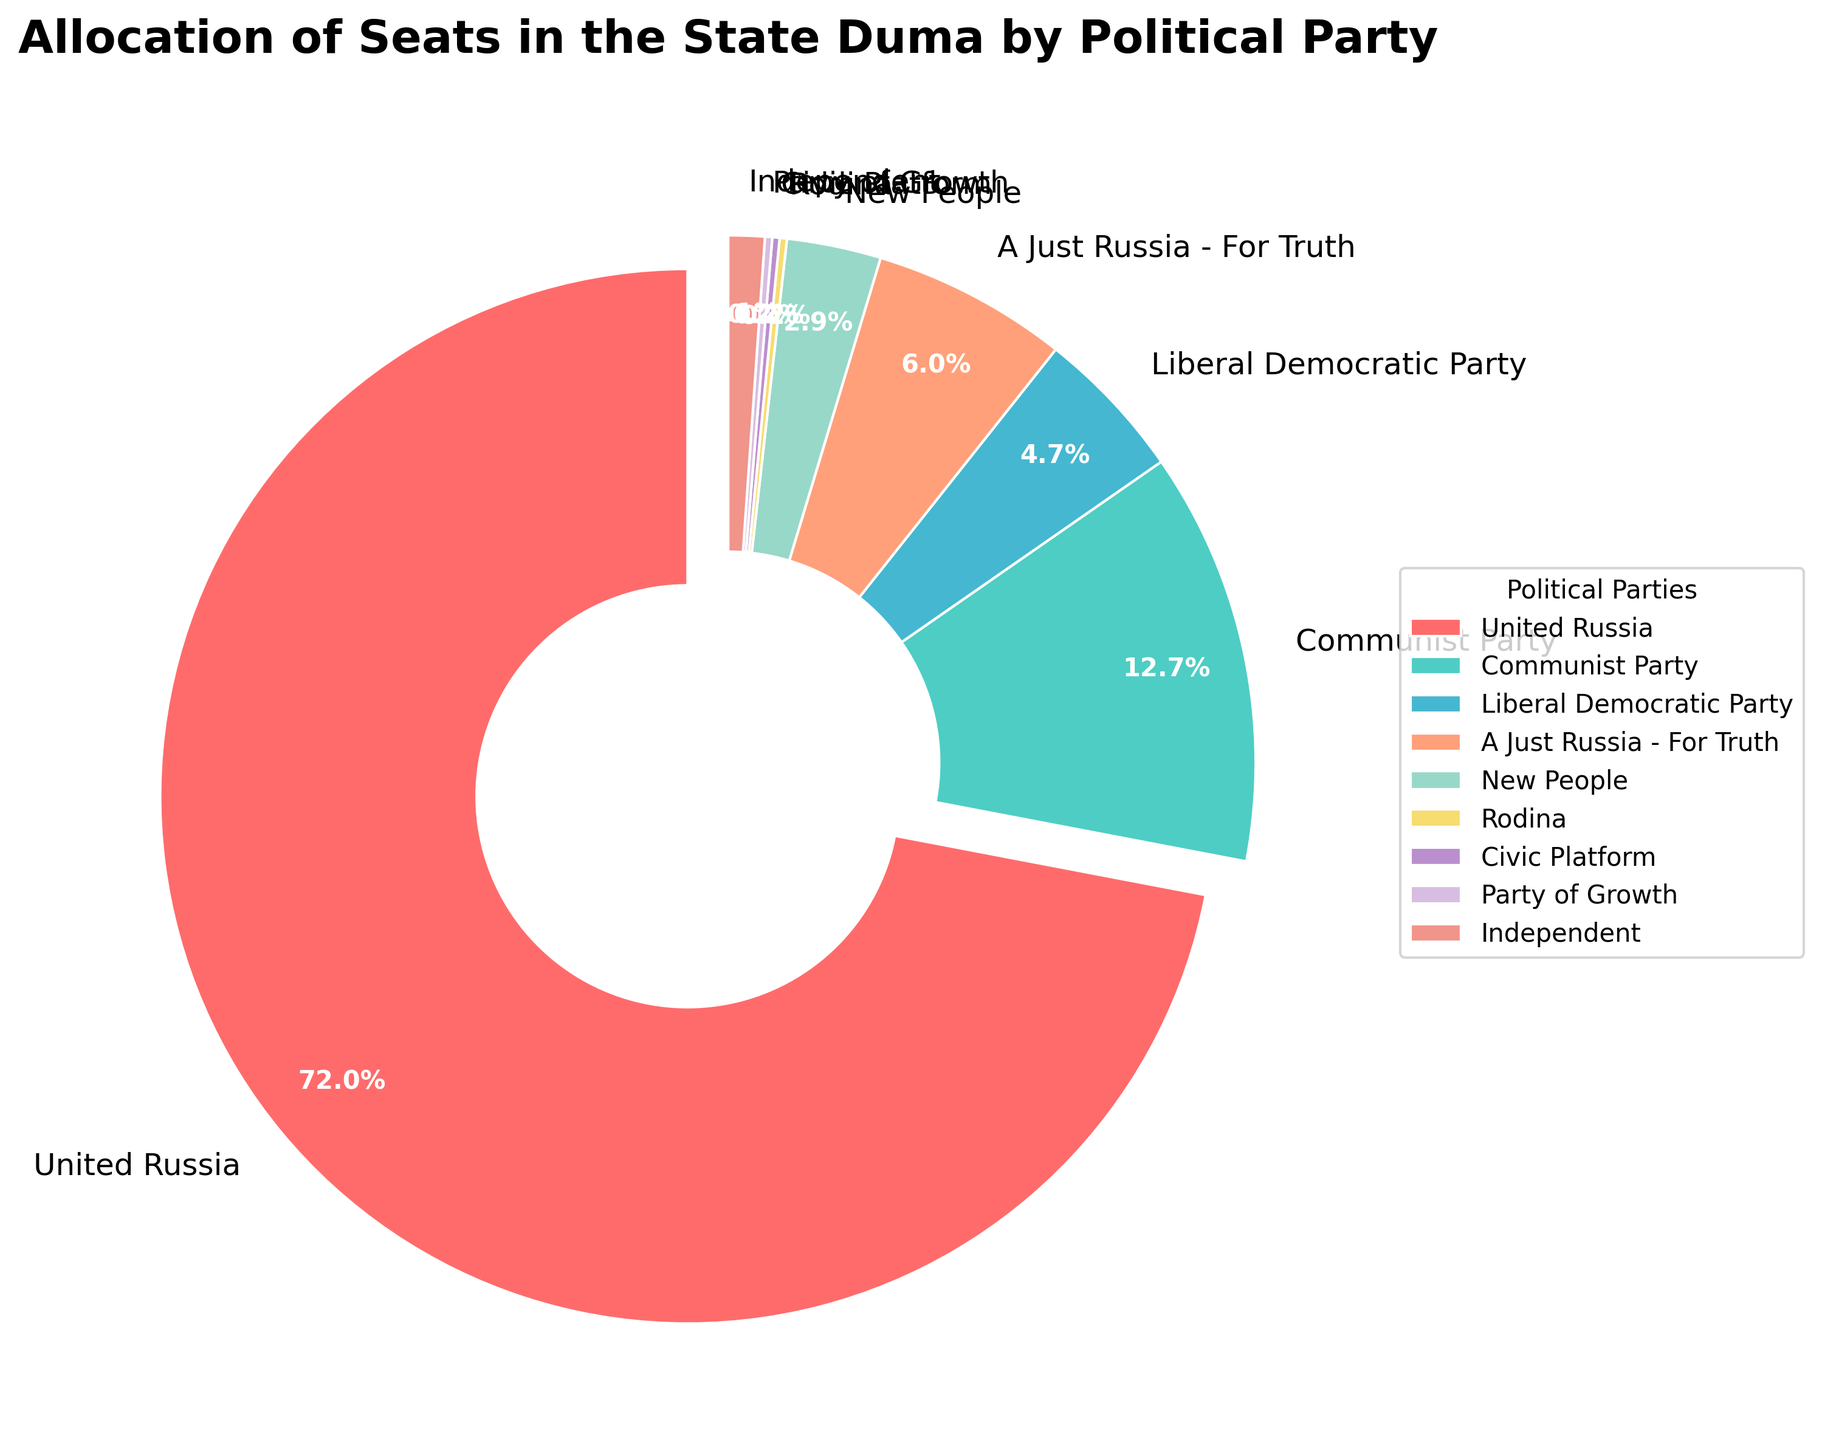What percentage of seats does the United Russia party have? Look at the portion of the pie chart labeled 'United Russia' and the percentage indicated on it.
Answer: 57.3% How many more seats does the Communist Party have compared to the Liberal Democratic Party? From the chart, the Communist Party has 57 seats and the Liberal Democratic Party has 21 seats. Subtract the number of seats of the Liberal Democratic Party from the number of seats of the Communist Party: 57 - 21.
Answer: 36 What is the total number of seats held by A Just Russia - For Truth and New People combined? Look at the number of seats for A Just Russia - For Truth (27) and New People (13). Add these numbers together: 27 + 13.
Answer: 40 Which party holds the smallest number of seats and what is its percentage? Identify the smallest section of the pie chart by size. Both Rodina, Civic Platform, and Party of Growth each have 1 seat. The percentage can be seen on the chart.
Answer: Rodina (0.2%) Which party is represented with the red color, and how many seats does it have? Identify the red-colored section of the pie chart and check the label. The corresponding label is 'United Russia' which has 324 seats.
Answer: United Russia (324 seats) Compare the number of seats between United Russia and all other parties combined. Which has more and by how many? From the chart, United Russia has 324 seats. The total number of seats is 450. All other parties combined would be 450 - 324 = 126. Subtract this from the seats held by United Russia: 324 - 126.
Answer: United Russia by 198 seats What is the combined percentage of the seats for parties other than United Russia and Communist Party? The combined percentage of United Russia (57.3%) and Communist Party (12.7%) is 70%. Subtract this from 100%: 100% - 70%.
Answer: 30% Which party has more seats: New People or Independents, and by how many? According to the pie chart, New People have 13 seats, and Independents have 5 seats. Subtract the number of seats of Independents from New People: 13 - 5.
Answer: New People (8 seats) What is the difference in the number of seats between the Liberal Democratic Party and A Just Russia - For Truth? The Liberal Democratic Party has 21 seats, and A Just Russia - For Truth has 27 seats. Subtract the number of seats of the Liberal Democratic Party from A Just Russia - For Truth: 27 - 21.
Answer: 6 What portion of the pie chart is allocated to Independent members? Look at the section labeled 'Independent' on the pie chart and note the percentage indicated there.
Answer: 1.1% 